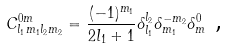Convert formula to latex. <formula><loc_0><loc_0><loc_500><loc_500>C _ { l _ { 1 } m _ { 1 } l _ { 2 } m _ { 2 } } ^ { 0 m } = \frac { ( - 1 ) ^ { m _ { 1 } } } { 2 l _ { 1 } + 1 } \delta _ { l _ { 1 } } ^ { l _ { 2 } } \delta _ { m _ { 1 } } ^ { - m _ { 2 } } \delta _ { m } ^ { 0 } \text { ,}</formula> 